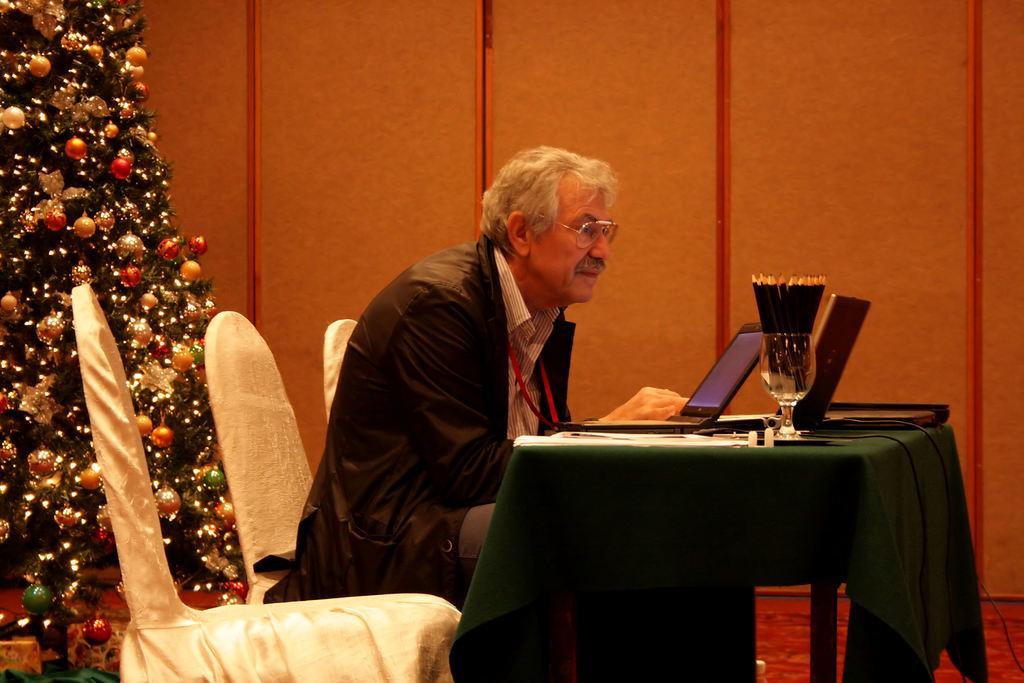Describe this image in one or two sentences. In this image, we can see a person wearing spectacles is sitting on a chair covered with white cloth. We can see a table covered with a green cloth and some objects like a laptop and a glass on it. On the left, we can see a Christmas tree. We can also see the wall. On the bottom right, we can see the floor. 